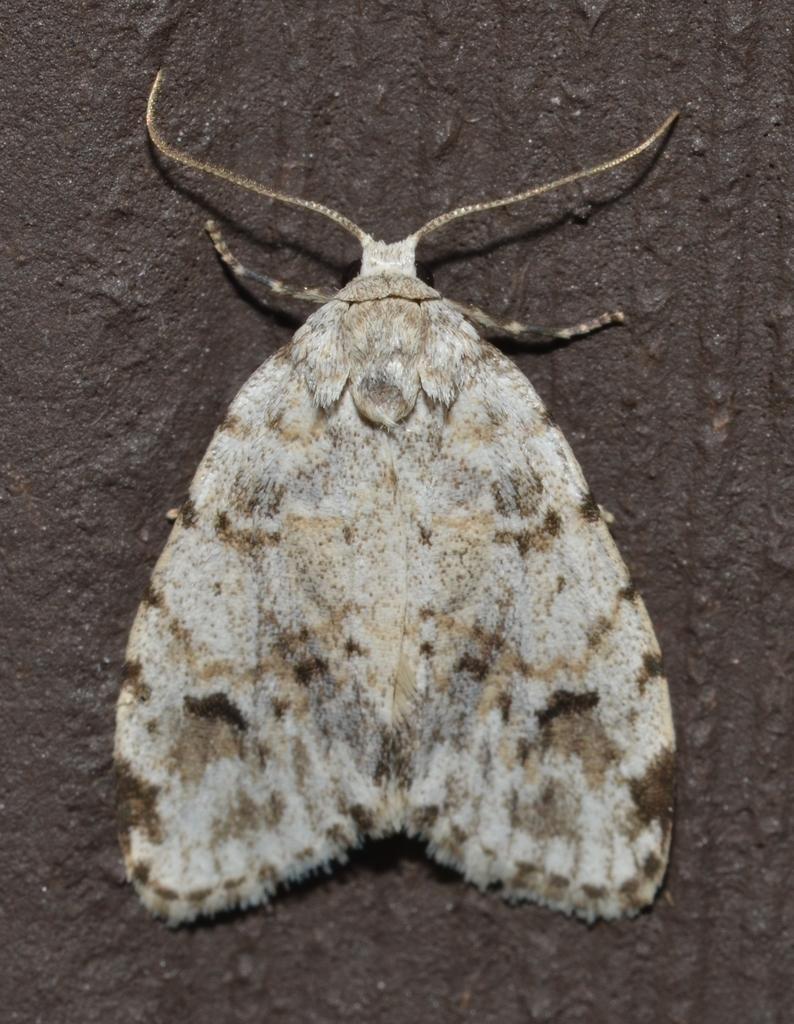In one or two sentences, can you explain what this image depicts? In this picture we can see a butterfly on a surface. 